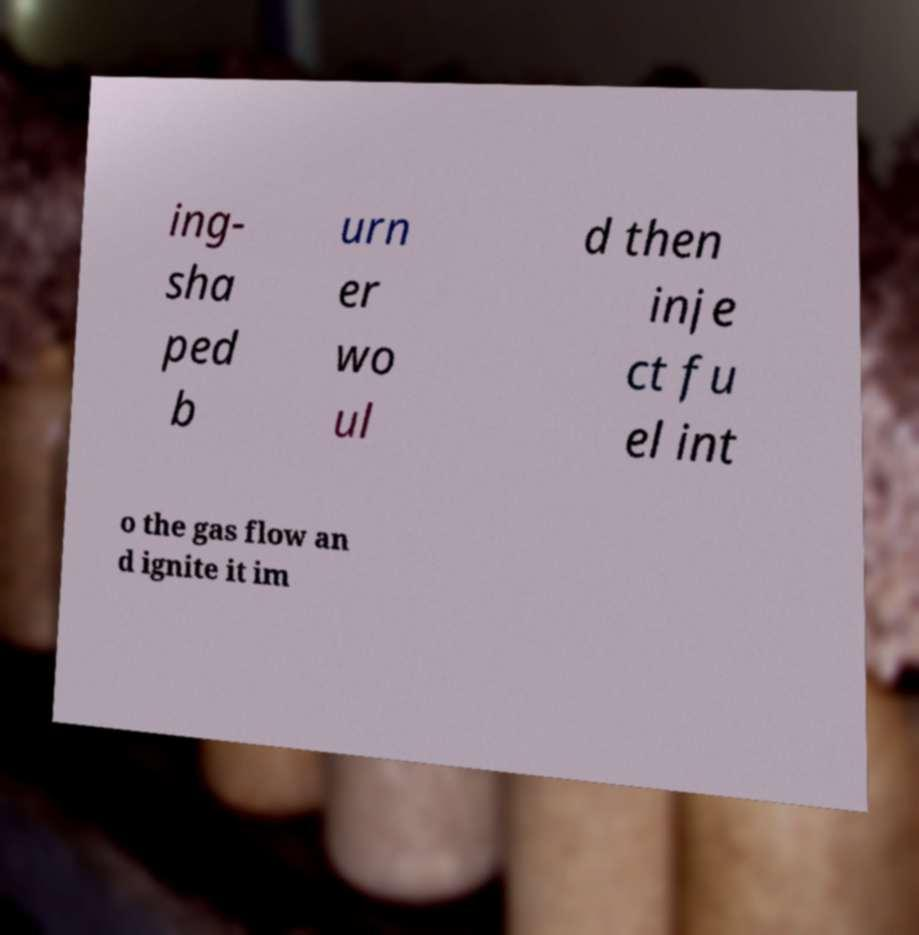For documentation purposes, I need the text within this image transcribed. Could you provide that? ing- sha ped b urn er wo ul d then inje ct fu el int o the gas flow an d ignite it im 